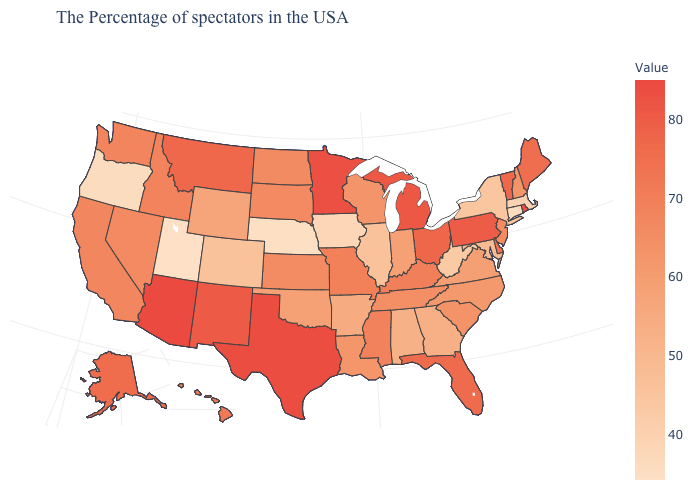Which states have the lowest value in the West?
Quick response, please. Utah. Does Nebraska have a higher value than Florida?
Short answer required. No. Does New Jersey have the lowest value in the USA?
Be succinct. No. Among the states that border North Carolina , does Tennessee have the highest value?
Short answer required. Yes. 